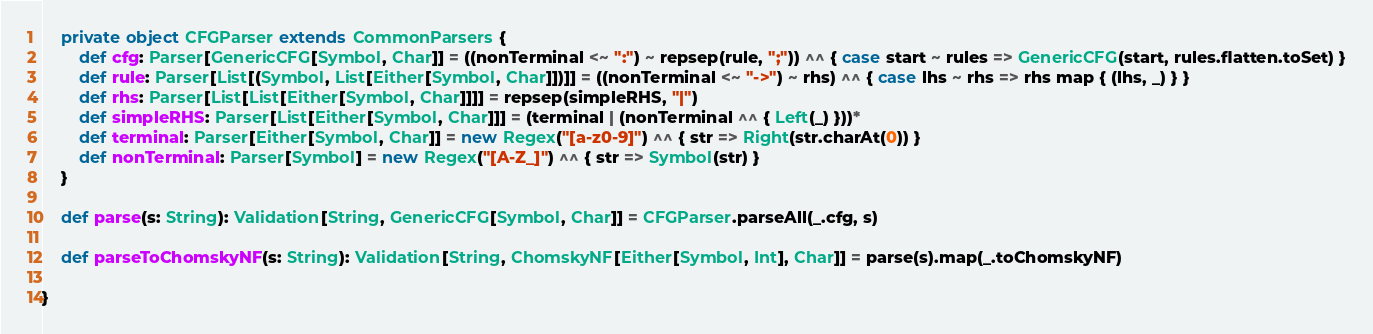<code> <loc_0><loc_0><loc_500><loc_500><_Scala_>
	private object CFGParser extends CommonParsers {
		def cfg: Parser[GenericCFG[Symbol, Char]] = ((nonTerminal <~ ":") ~ repsep(rule, ";")) ^^ { case start ~ rules => GenericCFG(start, rules.flatten.toSet) }
		def rule: Parser[List[(Symbol, List[Either[Symbol, Char]])]] = ((nonTerminal <~ "->") ~ rhs) ^^ { case lhs ~ rhs => rhs map { (lhs, _) } }
		def rhs: Parser[List[List[Either[Symbol, Char]]]] = repsep(simpleRHS, "|")
		def simpleRHS: Parser[List[Either[Symbol, Char]]] = (terminal | (nonTerminal ^^ { Left(_) }))*
		def terminal: Parser[Either[Symbol, Char]] = new Regex("[a-z0-9]") ^^ { str => Right(str.charAt(0)) }
		def nonTerminal: Parser[Symbol] = new Regex("[A-Z_]") ^^ { str => Symbol(str) }
	}

	def parse(s: String): Validation[String, GenericCFG[Symbol, Char]] = CFGParser.parseAll(_.cfg, s)

	def parseToChomskyNF(s: String): Validation[String, ChomskyNF[Either[Symbol, Int], Char]] = parse(s).map(_.toChomskyNF)

}
</code> 